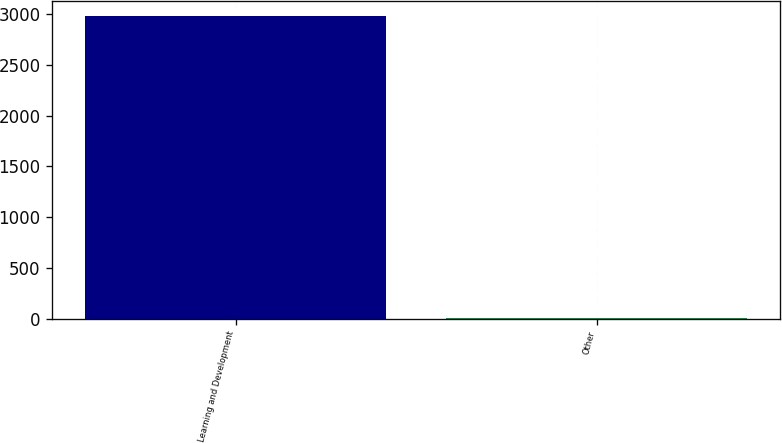Convert chart. <chart><loc_0><loc_0><loc_500><loc_500><bar_chart><fcel>Learning and Development<fcel>Other<nl><fcel>2981.6<fcel>3.5<nl></chart> 